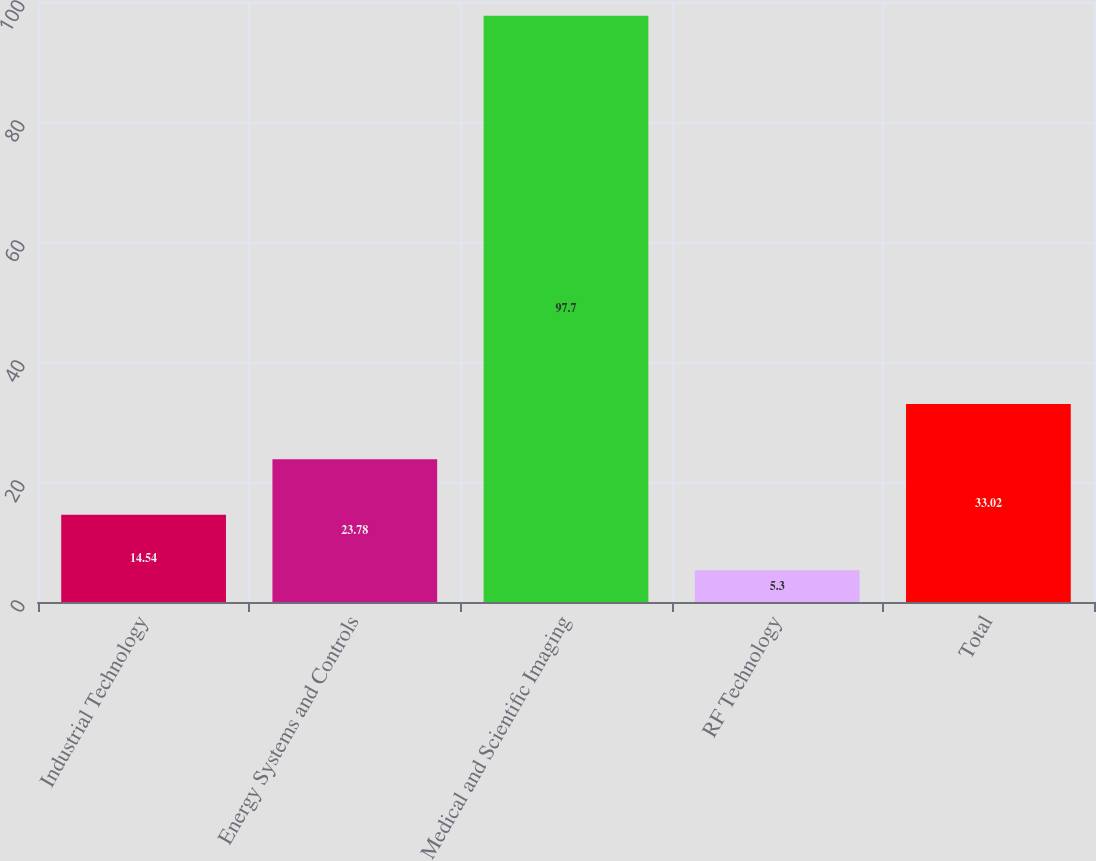<chart> <loc_0><loc_0><loc_500><loc_500><bar_chart><fcel>Industrial Technology<fcel>Energy Systems and Controls<fcel>Medical and Scientific Imaging<fcel>RF Technology<fcel>Total<nl><fcel>14.54<fcel>23.78<fcel>97.7<fcel>5.3<fcel>33.02<nl></chart> 